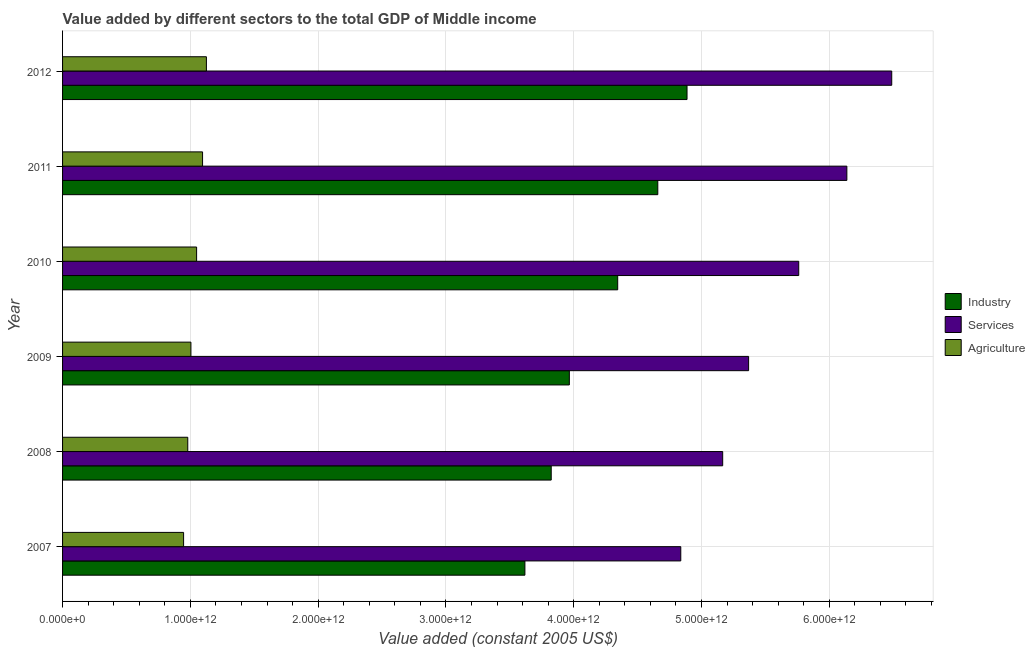Are the number of bars per tick equal to the number of legend labels?
Give a very brief answer. Yes. Are the number of bars on each tick of the Y-axis equal?
Your answer should be compact. Yes. How many bars are there on the 3rd tick from the top?
Offer a terse response. 3. What is the value added by industrial sector in 2008?
Make the answer very short. 3.82e+12. Across all years, what is the maximum value added by services?
Keep it short and to the point. 6.49e+12. Across all years, what is the minimum value added by industrial sector?
Make the answer very short. 3.62e+12. What is the total value added by industrial sector in the graph?
Ensure brevity in your answer.  2.53e+13. What is the difference between the value added by services in 2008 and that in 2012?
Your response must be concise. -1.32e+12. What is the difference between the value added by services in 2007 and the value added by agricultural sector in 2012?
Provide a succinct answer. 3.71e+12. What is the average value added by services per year?
Make the answer very short. 5.63e+12. In the year 2007, what is the difference between the value added by services and value added by industrial sector?
Offer a terse response. 1.22e+12. What is the ratio of the value added by services in 2007 to that in 2010?
Offer a terse response. 0.84. Is the value added by industrial sector in 2009 less than that in 2010?
Keep it short and to the point. Yes. What is the difference between the highest and the second highest value added by agricultural sector?
Your response must be concise. 3.01e+1. What is the difference between the highest and the lowest value added by services?
Your answer should be very brief. 1.65e+12. In how many years, is the value added by services greater than the average value added by services taken over all years?
Ensure brevity in your answer.  3. What does the 1st bar from the top in 2007 represents?
Provide a short and direct response. Agriculture. What does the 3rd bar from the bottom in 2008 represents?
Keep it short and to the point. Agriculture. Is it the case that in every year, the sum of the value added by industrial sector and value added by services is greater than the value added by agricultural sector?
Provide a succinct answer. Yes. How many bars are there?
Offer a terse response. 18. How many years are there in the graph?
Give a very brief answer. 6. What is the difference between two consecutive major ticks on the X-axis?
Offer a very short reply. 1.00e+12. Does the graph contain any zero values?
Give a very brief answer. No. How many legend labels are there?
Give a very brief answer. 3. What is the title of the graph?
Offer a terse response. Value added by different sectors to the total GDP of Middle income. What is the label or title of the X-axis?
Provide a succinct answer. Value added (constant 2005 US$). What is the Value added (constant 2005 US$) in Industry in 2007?
Give a very brief answer. 3.62e+12. What is the Value added (constant 2005 US$) of Services in 2007?
Offer a terse response. 4.84e+12. What is the Value added (constant 2005 US$) of Agriculture in 2007?
Ensure brevity in your answer.  9.47e+11. What is the Value added (constant 2005 US$) of Industry in 2008?
Keep it short and to the point. 3.82e+12. What is the Value added (constant 2005 US$) of Services in 2008?
Provide a succinct answer. 5.17e+12. What is the Value added (constant 2005 US$) of Agriculture in 2008?
Your answer should be compact. 9.80e+11. What is the Value added (constant 2005 US$) in Industry in 2009?
Offer a terse response. 3.97e+12. What is the Value added (constant 2005 US$) in Services in 2009?
Provide a short and direct response. 5.37e+12. What is the Value added (constant 2005 US$) in Agriculture in 2009?
Provide a succinct answer. 1.00e+12. What is the Value added (constant 2005 US$) in Industry in 2010?
Keep it short and to the point. 4.34e+12. What is the Value added (constant 2005 US$) in Services in 2010?
Provide a succinct answer. 5.76e+12. What is the Value added (constant 2005 US$) in Agriculture in 2010?
Give a very brief answer. 1.05e+12. What is the Value added (constant 2005 US$) of Industry in 2011?
Offer a terse response. 4.66e+12. What is the Value added (constant 2005 US$) in Services in 2011?
Offer a terse response. 6.14e+12. What is the Value added (constant 2005 US$) of Agriculture in 2011?
Keep it short and to the point. 1.10e+12. What is the Value added (constant 2005 US$) of Industry in 2012?
Keep it short and to the point. 4.89e+12. What is the Value added (constant 2005 US$) of Services in 2012?
Your answer should be compact. 6.49e+12. What is the Value added (constant 2005 US$) in Agriculture in 2012?
Provide a short and direct response. 1.13e+12. Across all years, what is the maximum Value added (constant 2005 US$) of Industry?
Provide a short and direct response. 4.89e+12. Across all years, what is the maximum Value added (constant 2005 US$) in Services?
Ensure brevity in your answer.  6.49e+12. Across all years, what is the maximum Value added (constant 2005 US$) in Agriculture?
Your response must be concise. 1.13e+12. Across all years, what is the minimum Value added (constant 2005 US$) in Industry?
Provide a short and direct response. 3.62e+12. Across all years, what is the minimum Value added (constant 2005 US$) of Services?
Offer a terse response. 4.84e+12. Across all years, what is the minimum Value added (constant 2005 US$) in Agriculture?
Your response must be concise. 9.47e+11. What is the total Value added (constant 2005 US$) of Industry in the graph?
Provide a short and direct response. 2.53e+13. What is the total Value added (constant 2005 US$) in Services in the graph?
Provide a short and direct response. 3.38e+13. What is the total Value added (constant 2005 US$) in Agriculture in the graph?
Ensure brevity in your answer.  6.20e+12. What is the difference between the Value added (constant 2005 US$) of Industry in 2007 and that in 2008?
Your answer should be compact. -2.06e+11. What is the difference between the Value added (constant 2005 US$) in Services in 2007 and that in 2008?
Ensure brevity in your answer.  -3.28e+11. What is the difference between the Value added (constant 2005 US$) of Agriculture in 2007 and that in 2008?
Offer a terse response. -3.27e+1. What is the difference between the Value added (constant 2005 US$) of Industry in 2007 and that in 2009?
Provide a short and direct response. -3.48e+11. What is the difference between the Value added (constant 2005 US$) in Services in 2007 and that in 2009?
Keep it short and to the point. -5.31e+11. What is the difference between the Value added (constant 2005 US$) of Agriculture in 2007 and that in 2009?
Your answer should be compact. -5.74e+1. What is the difference between the Value added (constant 2005 US$) of Industry in 2007 and that in 2010?
Provide a short and direct response. -7.26e+11. What is the difference between the Value added (constant 2005 US$) in Services in 2007 and that in 2010?
Give a very brief answer. -9.23e+11. What is the difference between the Value added (constant 2005 US$) in Agriculture in 2007 and that in 2010?
Offer a terse response. -1.02e+11. What is the difference between the Value added (constant 2005 US$) in Industry in 2007 and that in 2011?
Your answer should be very brief. -1.04e+12. What is the difference between the Value added (constant 2005 US$) of Services in 2007 and that in 2011?
Provide a succinct answer. -1.30e+12. What is the difference between the Value added (constant 2005 US$) in Agriculture in 2007 and that in 2011?
Ensure brevity in your answer.  -1.48e+11. What is the difference between the Value added (constant 2005 US$) of Industry in 2007 and that in 2012?
Offer a terse response. -1.27e+12. What is the difference between the Value added (constant 2005 US$) in Services in 2007 and that in 2012?
Your response must be concise. -1.65e+12. What is the difference between the Value added (constant 2005 US$) of Agriculture in 2007 and that in 2012?
Your response must be concise. -1.79e+11. What is the difference between the Value added (constant 2005 US$) in Industry in 2008 and that in 2009?
Your response must be concise. -1.42e+11. What is the difference between the Value added (constant 2005 US$) in Services in 2008 and that in 2009?
Your response must be concise. -2.03e+11. What is the difference between the Value added (constant 2005 US$) of Agriculture in 2008 and that in 2009?
Your answer should be very brief. -2.47e+1. What is the difference between the Value added (constant 2005 US$) in Industry in 2008 and that in 2010?
Offer a terse response. -5.20e+11. What is the difference between the Value added (constant 2005 US$) of Services in 2008 and that in 2010?
Your answer should be compact. -5.95e+11. What is the difference between the Value added (constant 2005 US$) of Agriculture in 2008 and that in 2010?
Offer a very short reply. -6.91e+1. What is the difference between the Value added (constant 2005 US$) in Industry in 2008 and that in 2011?
Make the answer very short. -8.34e+11. What is the difference between the Value added (constant 2005 US$) of Services in 2008 and that in 2011?
Offer a terse response. -9.72e+11. What is the difference between the Value added (constant 2005 US$) in Agriculture in 2008 and that in 2011?
Your response must be concise. -1.16e+11. What is the difference between the Value added (constant 2005 US$) of Industry in 2008 and that in 2012?
Your answer should be compact. -1.06e+12. What is the difference between the Value added (constant 2005 US$) in Services in 2008 and that in 2012?
Offer a terse response. -1.32e+12. What is the difference between the Value added (constant 2005 US$) in Agriculture in 2008 and that in 2012?
Your answer should be very brief. -1.46e+11. What is the difference between the Value added (constant 2005 US$) of Industry in 2009 and that in 2010?
Provide a succinct answer. -3.79e+11. What is the difference between the Value added (constant 2005 US$) in Services in 2009 and that in 2010?
Provide a succinct answer. -3.92e+11. What is the difference between the Value added (constant 2005 US$) of Agriculture in 2009 and that in 2010?
Give a very brief answer. -4.44e+1. What is the difference between the Value added (constant 2005 US$) in Industry in 2009 and that in 2011?
Your answer should be very brief. -6.92e+11. What is the difference between the Value added (constant 2005 US$) of Services in 2009 and that in 2011?
Your response must be concise. -7.69e+11. What is the difference between the Value added (constant 2005 US$) of Agriculture in 2009 and that in 2011?
Your response must be concise. -9.10e+1. What is the difference between the Value added (constant 2005 US$) in Industry in 2009 and that in 2012?
Offer a terse response. -9.21e+11. What is the difference between the Value added (constant 2005 US$) of Services in 2009 and that in 2012?
Your response must be concise. -1.12e+12. What is the difference between the Value added (constant 2005 US$) in Agriculture in 2009 and that in 2012?
Provide a succinct answer. -1.21e+11. What is the difference between the Value added (constant 2005 US$) of Industry in 2010 and that in 2011?
Offer a very short reply. -3.14e+11. What is the difference between the Value added (constant 2005 US$) of Services in 2010 and that in 2011?
Make the answer very short. -3.77e+11. What is the difference between the Value added (constant 2005 US$) in Agriculture in 2010 and that in 2011?
Make the answer very short. -4.66e+1. What is the difference between the Value added (constant 2005 US$) of Industry in 2010 and that in 2012?
Offer a very short reply. -5.42e+11. What is the difference between the Value added (constant 2005 US$) of Services in 2010 and that in 2012?
Ensure brevity in your answer.  -7.28e+11. What is the difference between the Value added (constant 2005 US$) of Agriculture in 2010 and that in 2012?
Your answer should be very brief. -7.67e+1. What is the difference between the Value added (constant 2005 US$) in Industry in 2011 and that in 2012?
Your response must be concise. -2.29e+11. What is the difference between the Value added (constant 2005 US$) of Services in 2011 and that in 2012?
Offer a terse response. -3.51e+11. What is the difference between the Value added (constant 2005 US$) of Agriculture in 2011 and that in 2012?
Your answer should be very brief. -3.01e+1. What is the difference between the Value added (constant 2005 US$) of Industry in 2007 and the Value added (constant 2005 US$) of Services in 2008?
Your answer should be very brief. -1.55e+12. What is the difference between the Value added (constant 2005 US$) in Industry in 2007 and the Value added (constant 2005 US$) in Agriculture in 2008?
Give a very brief answer. 2.64e+12. What is the difference between the Value added (constant 2005 US$) in Services in 2007 and the Value added (constant 2005 US$) in Agriculture in 2008?
Provide a succinct answer. 3.86e+12. What is the difference between the Value added (constant 2005 US$) of Industry in 2007 and the Value added (constant 2005 US$) of Services in 2009?
Ensure brevity in your answer.  -1.75e+12. What is the difference between the Value added (constant 2005 US$) of Industry in 2007 and the Value added (constant 2005 US$) of Agriculture in 2009?
Your answer should be compact. 2.61e+12. What is the difference between the Value added (constant 2005 US$) of Services in 2007 and the Value added (constant 2005 US$) of Agriculture in 2009?
Keep it short and to the point. 3.83e+12. What is the difference between the Value added (constant 2005 US$) in Industry in 2007 and the Value added (constant 2005 US$) in Services in 2010?
Your response must be concise. -2.14e+12. What is the difference between the Value added (constant 2005 US$) in Industry in 2007 and the Value added (constant 2005 US$) in Agriculture in 2010?
Provide a succinct answer. 2.57e+12. What is the difference between the Value added (constant 2005 US$) in Services in 2007 and the Value added (constant 2005 US$) in Agriculture in 2010?
Provide a short and direct response. 3.79e+12. What is the difference between the Value added (constant 2005 US$) of Industry in 2007 and the Value added (constant 2005 US$) of Services in 2011?
Keep it short and to the point. -2.52e+12. What is the difference between the Value added (constant 2005 US$) of Industry in 2007 and the Value added (constant 2005 US$) of Agriculture in 2011?
Keep it short and to the point. 2.52e+12. What is the difference between the Value added (constant 2005 US$) in Services in 2007 and the Value added (constant 2005 US$) in Agriculture in 2011?
Make the answer very short. 3.74e+12. What is the difference between the Value added (constant 2005 US$) of Industry in 2007 and the Value added (constant 2005 US$) of Services in 2012?
Provide a succinct answer. -2.87e+12. What is the difference between the Value added (constant 2005 US$) of Industry in 2007 and the Value added (constant 2005 US$) of Agriculture in 2012?
Your answer should be compact. 2.49e+12. What is the difference between the Value added (constant 2005 US$) of Services in 2007 and the Value added (constant 2005 US$) of Agriculture in 2012?
Give a very brief answer. 3.71e+12. What is the difference between the Value added (constant 2005 US$) in Industry in 2008 and the Value added (constant 2005 US$) in Services in 2009?
Provide a short and direct response. -1.54e+12. What is the difference between the Value added (constant 2005 US$) of Industry in 2008 and the Value added (constant 2005 US$) of Agriculture in 2009?
Provide a succinct answer. 2.82e+12. What is the difference between the Value added (constant 2005 US$) in Services in 2008 and the Value added (constant 2005 US$) in Agriculture in 2009?
Your response must be concise. 4.16e+12. What is the difference between the Value added (constant 2005 US$) in Industry in 2008 and the Value added (constant 2005 US$) in Services in 2010?
Ensure brevity in your answer.  -1.94e+12. What is the difference between the Value added (constant 2005 US$) of Industry in 2008 and the Value added (constant 2005 US$) of Agriculture in 2010?
Make the answer very short. 2.78e+12. What is the difference between the Value added (constant 2005 US$) of Services in 2008 and the Value added (constant 2005 US$) of Agriculture in 2010?
Ensure brevity in your answer.  4.12e+12. What is the difference between the Value added (constant 2005 US$) in Industry in 2008 and the Value added (constant 2005 US$) in Services in 2011?
Offer a terse response. -2.31e+12. What is the difference between the Value added (constant 2005 US$) of Industry in 2008 and the Value added (constant 2005 US$) of Agriculture in 2011?
Make the answer very short. 2.73e+12. What is the difference between the Value added (constant 2005 US$) of Services in 2008 and the Value added (constant 2005 US$) of Agriculture in 2011?
Make the answer very short. 4.07e+12. What is the difference between the Value added (constant 2005 US$) of Industry in 2008 and the Value added (constant 2005 US$) of Services in 2012?
Keep it short and to the point. -2.66e+12. What is the difference between the Value added (constant 2005 US$) in Industry in 2008 and the Value added (constant 2005 US$) in Agriculture in 2012?
Your answer should be very brief. 2.70e+12. What is the difference between the Value added (constant 2005 US$) of Services in 2008 and the Value added (constant 2005 US$) of Agriculture in 2012?
Keep it short and to the point. 4.04e+12. What is the difference between the Value added (constant 2005 US$) of Industry in 2009 and the Value added (constant 2005 US$) of Services in 2010?
Your answer should be very brief. -1.80e+12. What is the difference between the Value added (constant 2005 US$) in Industry in 2009 and the Value added (constant 2005 US$) in Agriculture in 2010?
Give a very brief answer. 2.92e+12. What is the difference between the Value added (constant 2005 US$) in Services in 2009 and the Value added (constant 2005 US$) in Agriculture in 2010?
Make the answer very short. 4.32e+12. What is the difference between the Value added (constant 2005 US$) of Industry in 2009 and the Value added (constant 2005 US$) of Services in 2011?
Your response must be concise. -2.17e+12. What is the difference between the Value added (constant 2005 US$) of Industry in 2009 and the Value added (constant 2005 US$) of Agriculture in 2011?
Make the answer very short. 2.87e+12. What is the difference between the Value added (constant 2005 US$) in Services in 2009 and the Value added (constant 2005 US$) in Agriculture in 2011?
Your response must be concise. 4.27e+12. What is the difference between the Value added (constant 2005 US$) in Industry in 2009 and the Value added (constant 2005 US$) in Services in 2012?
Ensure brevity in your answer.  -2.52e+12. What is the difference between the Value added (constant 2005 US$) of Industry in 2009 and the Value added (constant 2005 US$) of Agriculture in 2012?
Your answer should be compact. 2.84e+12. What is the difference between the Value added (constant 2005 US$) in Services in 2009 and the Value added (constant 2005 US$) in Agriculture in 2012?
Provide a succinct answer. 4.24e+12. What is the difference between the Value added (constant 2005 US$) in Industry in 2010 and the Value added (constant 2005 US$) in Services in 2011?
Give a very brief answer. -1.79e+12. What is the difference between the Value added (constant 2005 US$) in Industry in 2010 and the Value added (constant 2005 US$) in Agriculture in 2011?
Your answer should be very brief. 3.25e+12. What is the difference between the Value added (constant 2005 US$) in Services in 2010 and the Value added (constant 2005 US$) in Agriculture in 2011?
Your answer should be compact. 4.67e+12. What is the difference between the Value added (constant 2005 US$) in Industry in 2010 and the Value added (constant 2005 US$) in Services in 2012?
Your answer should be compact. -2.14e+12. What is the difference between the Value added (constant 2005 US$) in Industry in 2010 and the Value added (constant 2005 US$) in Agriculture in 2012?
Your answer should be compact. 3.22e+12. What is the difference between the Value added (constant 2005 US$) in Services in 2010 and the Value added (constant 2005 US$) in Agriculture in 2012?
Your response must be concise. 4.64e+12. What is the difference between the Value added (constant 2005 US$) of Industry in 2011 and the Value added (constant 2005 US$) of Services in 2012?
Keep it short and to the point. -1.83e+12. What is the difference between the Value added (constant 2005 US$) of Industry in 2011 and the Value added (constant 2005 US$) of Agriculture in 2012?
Ensure brevity in your answer.  3.53e+12. What is the difference between the Value added (constant 2005 US$) in Services in 2011 and the Value added (constant 2005 US$) in Agriculture in 2012?
Your answer should be compact. 5.01e+12. What is the average Value added (constant 2005 US$) of Industry per year?
Keep it short and to the point. 4.22e+12. What is the average Value added (constant 2005 US$) in Services per year?
Make the answer very short. 5.63e+12. What is the average Value added (constant 2005 US$) in Agriculture per year?
Offer a very short reply. 1.03e+12. In the year 2007, what is the difference between the Value added (constant 2005 US$) of Industry and Value added (constant 2005 US$) of Services?
Your response must be concise. -1.22e+12. In the year 2007, what is the difference between the Value added (constant 2005 US$) in Industry and Value added (constant 2005 US$) in Agriculture?
Provide a short and direct response. 2.67e+12. In the year 2007, what is the difference between the Value added (constant 2005 US$) in Services and Value added (constant 2005 US$) in Agriculture?
Keep it short and to the point. 3.89e+12. In the year 2008, what is the difference between the Value added (constant 2005 US$) in Industry and Value added (constant 2005 US$) in Services?
Keep it short and to the point. -1.34e+12. In the year 2008, what is the difference between the Value added (constant 2005 US$) of Industry and Value added (constant 2005 US$) of Agriculture?
Your answer should be compact. 2.84e+12. In the year 2008, what is the difference between the Value added (constant 2005 US$) in Services and Value added (constant 2005 US$) in Agriculture?
Your answer should be compact. 4.19e+12. In the year 2009, what is the difference between the Value added (constant 2005 US$) in Industry and Value added (constant 2005 US$) in Services?
Provide a succinct answer. -1.40e+12. In the year 2009, what is the difference between the Value added (constant 2005 US$) of Industry and Value added (constant 2005 US$) of Agriculture?
Your answer should be compact. 2.96e+12. In the year 2009, what is the difference between the Value added (constant 2005 US$) of Services and Value added (constant 2005 US$) of Agriculture?
Keep it short and to the point. 4.36e+12. In the year 2010, what is the difference between the Value added (constant 2005 US$) in Industry and Value added (constant 2005 US$) in Services?
Ensure brevity in your answer.  -1.42e+12. In the year 2010, what is the difference between the Value added (constant 2005 US$) in Industry and Value added (constant 2005 US$) in Agriculture?
Make the answer very short. 3.30e+12. In the year 2010, what is the difference between the Value added (constant 2005 US$) in Services and Value added (constant 2005 US$) in Agriculture?
Provide a succinct answer. 4.71e+12. In the year 2011, what is the difference between the Value added (constant 2005 US$) in Industry and Value added (constant 2005 US$) in Services?
Your answer should be compact. -1.48e+12. In the year 2011, what is the difference between the Value added (constant 2005 US$) of Industry and Value added (constant 2005 US$) of Agriculture?
Your answer should be very brief. 3.56e+12. In the year 2011, what is the difference between the Value added (constant 2005 US$) of Services and Value added (constant 2005 US$) of Agriculture?
Provide a short and direct response. 5.04e+12. In the year 2012, what is the difference between the Value added (constant 2005 US$) of Industry and Value added (constant 2005 US$) of Services?
Give a very brief answer. -1.60e+12. In the year 2012, what is the difference between the Value added (constant 2005 US$) of Industry and Value added (constant 2005 US$) of Agriculture?
Your response must be concise. 3.76e+12. In the year 2012, what is the difference between the Value added (constant 2005 US$) in Services and Value added (constant 2005 US$) in Agriculture?
Make the answer very short. 5.36e+12. What is the ratio of the Value added (constant 2005 US$) of Industry in 2007 to that in 2008?
Keep it short and to the point. 0.95. What is the ratio of the Value added (constant 2005 US$) of Services in 2007 to that in 2008?
Provide a succinct answer. 0.94. What is the ratio of the Value added (constant 2005 US$) in Agriculture in 2007 to that in 2008?
Give a very brief answer. 0.97. What is the ratio of the Value added (constant 2005 US$) in Industry in 2007 to that in 2009?
Your answer should be compact. 0.91. What is the ratio of the Value added (constant 2005 US$) of Services in 2007 to that in 2009?
Your answer should be very brief. 0.9. What is the ratio of the Value added (constant 2005 US$) of Agriculture in 2007 to that in 2009?
Ensure brevity in your answer.  0.94. What is the ratio of the Value added (constant 2005 US$) of Industry in 2007 to that in 2010?
Keep it short and to the point. 0.83. What is the ratio of the Value added (constant 2005 US$) in Services in 2007 to that in 2010?
Your answer should be very brief. 0.84. What is the ratio of the Value added (constant 2005 US$) of Agriculture in 2007 to that in 2010?
Give a very brief answer. 0.9. What is the ratio of the Value added (constant 2005 US$) of Industry in 2007 to that in 2011?
Give a very brief answer. 0.78. What is the ratio of the Value added (constant 2005 US$) in Services in 2007 to that in 2011?
Keep it short and to the point. 0.79. What is the ratio of the Value added (constant 2005 US$) of Agriculture in 2007 to that in 2011?
Your answer should be compact. 0.86. What is the ratio of the Value added (constant 2005 US$) in Industry in 2007 to that in 2012?
Your response must be concise. 0.74. What is the ratio of the Value added (constant 2005 US$) of Services in 2007 to that in 2012?
Ensure brevity in your answer.  0.75. What is the ratio of the Value added (constant 2005 US$) of Agriculture in 2007 to that in 2012?
Your response must be concise. 0.84. What is the ratio of the Value added (constant 2005 US$) in Services in 2008 to that in 2009?
Keep it short and to the point. 0.96. What is the ratio of the Value added (constant 2005 US$) of Agriculture in 2008 to that in 2009?
Offer a terse response. 0.98. What is the ratio of the Value added (constant 2005 US$) in Industry in 2008 to that in 2010?
Provide a succinct answer. 0.88. What is the ratio of the Value added (constant 2005 US$) of Services in 2008 to that in 2010?
Make the answer very short. 0.9. What is the ratio of the Value added (constant 2005 US$) in Agriculture in 2008 to that in 2010?
Provide a succinct answer. 0.93. What is the ratio of the Value added (constant 2005 US$) of Industry in 2008 to that in 2011?
Keep it short and to the point. 0.82. What is the ratio of the Value added (constant 2005 US$) of Services in 2008 to that in 2011?
Ensure brevity in your answer.  0.84. What is the ratio of the Value added (constant 2005 US$) of Agriculture in 2008 to that in 2011?
Make the answer very short. 0.89. What is the ratio of the Value added (constant 2005 US$) in Industry in 2008 to that in 2012?
Keep it short and to the point. 0.78. What is the ratio of the Value added (constant 2005 US$) in Services in 2008 to that in 2012?
Your answer should be compact. 0.8. What is the ratio of the Value added (constant 2005 US$) of Agriculture in 2008 to that in 2012?
Your response must be concise. 0.87. What is the ratio of the Value added (constant 2005 US$) in Industry in 2009 to that in 2010?
Your answer should be very brief. 0.91. What is the ratio of the Value added (constant 2005 US$) in Services in 2009 to that in 2010?
Your answer should be very brief. 0.93. What is the ratio of the Value added (constant 2005 US$) in Agriculture in 2009 to that in 2010?
Offer a very short reply. 0.96. What is the ratio of the Value added (constant 2005 US$) in Industry in 2009 to that in 2011?
Your answer should be compact. 0.85. What is the ratio of the Value added (constant 2005 US$) in Services in 2009 to that in 2011?
Offer a very short reply. 0.87. What is the ratio of the Value added (constant 2005 US$) of Agriculture in 2009 to that in 2011?
Provide a short and direct response. 0.92. What is the ratio of the Value added (constant 2005 US$) in Industry in 2009 to that in 2012?
Make the answer very short. 0.81. What is the ratio of the Value added (constant 2005 US$) in Services in 2009 to that in 2012?
Make the answer very short. 0.83. What is the ratio of the Value added (constant 2005 US$) of Agriculture in 2009 to that in 2012?
Your answer should be compact. 0.89. What is the ratio of the Value added (constant 2005 US$) in Industry in 2010 to that in 2011?
Offer a very short reply. 0.93. What is the ratio of the Value added (constant 2005 US$) of Services in 2010 to that in 2011?
Provide a short and direct response. 0.94. What is the ratio of the Value added (constant 2005 US$) in Agriculture in 2010 to that in 2011?
Your answer should be compact. 0.96. What is the ratio of the Value added (constant 2005 US$) of Industry in 2010 to that in 2012?
Offer a very short reply. 0.89. What is the ratio of the Value added (constant 2005 US$) of Services in 2010 to that in 2012?
Provide a short and direct response. 0.89. What is the ratio of the Value added (constant 2005 US$) in Agriculture in 2010 to that in 2012?
Ensure brevity in your answer.  0.93. What is the ratio of the Value added (constant 2005 US$) in Industry in 2011 to that in 2012?
Your response must be concise. 0.95. What is the ratio of the Value added (constant 2005 US$) of Services in 2011 to that in 2012?
Your response must be concise. 0.95. What is the ratio of the Value added (constant 2005 US$) of Agriculture in 2011 to that in 2012?
Offer a terse response. 0.97. What is the difference between the highest and the second highest Value added (constant 2005 US$) in Industry?
Offer a very short reply. 2.29e+11. What is the difference between the highest and the second highest Value added (constant 2005 US$) of Services?
Make the answer very short. 3.51e+11. What is the difference between the highest and the second highest Value added (constant 2005 US$) in Agriculture?
Your answer should be compact. 3.01e+1. What is the difference between the highest and the lowest Value added (constant 2005 US$) of Industry?
Provide a short and direct response. 1.27e+12. What is the difference between the highest and the lowest Value added (constant 2005 US$) in Services?
Provide a succinct answer. 1.65e+12. What is the difference between the highest and the lowest Value added (constant 2005 US$) of Agriculture?
Give a very brief answer. 1.79e+11. 